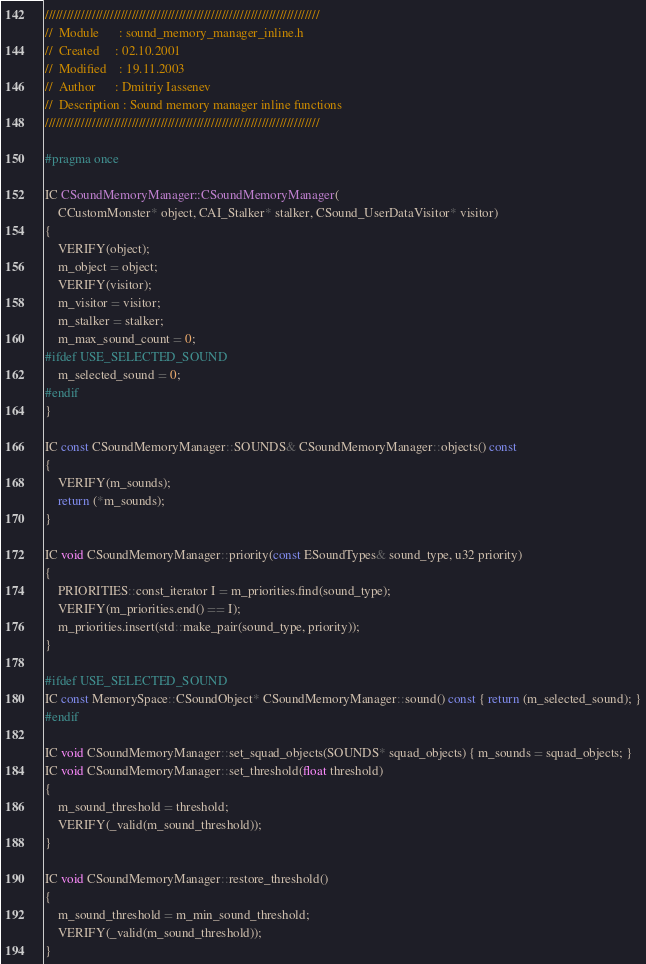Convert code to text. <code><loc_0><loc_0><loc_500><loc_500><_C_>////////////////////////////////////////////////////////////////////////////
//	Module 		: sound_memory_manager_inline.h
//	Created 	: 02.10.2001
//  Modified 	: 19.11.2003
//	Author		: Dmitriy Iassenev
//	Description : Sound memory manager inline functions
////////////////////////////////////////////////////////////////////////////

#pragma once

IC CSoundMemoryManager::CSoundMemoryManager(
    CCustomMonster* object, CAI_Stalker* stalker, CSound_UserDataVisitor* visitor)
{
    VERIFY(object);
    m_object = object;
    VERIFY(visitor);
    m_visitor = visitor;
    m_stalker = stalker;
    m_max_sound_count = 0;
#ifdef USE_SELECTED_SOUND
    m_selected_sound = 0;
#endif
}

IC const CSoundMemoryManager::SOUNDS& CSoundMemoryManager::objects() const
{
    VERIFY(m_sounds);
    return (*m_sounds);
}

IC void CSoundMemoryManager::priority(const ESoundTypes& sound_type, u32 priority)
{
    PRIORITIES::const_iterator I = m_priorities.find(sound_type);
    VERIFY(m_priorities.end() == I);
    m_priorities.insert(std::make_pair(sound_type, priority));
}

#ifdef USE_SELECTED_SOUND
IC const MemorySpace::CSoundObject* CSoundMemoryManager::sound() const { return (m_selected_sound); }
#endif

IC void CSoundMemoryManager::set_squad_objects(SOUNDS* squad_objects) { m_sounds = squad_objects; }
IC void CSoundMemoryManager::set_threshold(float threshold)
{
    m_sound_threshold = threshold;
    VERIFY(_valid(m_sound_threshold));
}

IC void CSoundMemoryManager::restore_threshold()
{
    m_sound_threshold = m_min_sound_threshold;
    VERIFY(_valid(m_sound_threshold));
}
</code> 